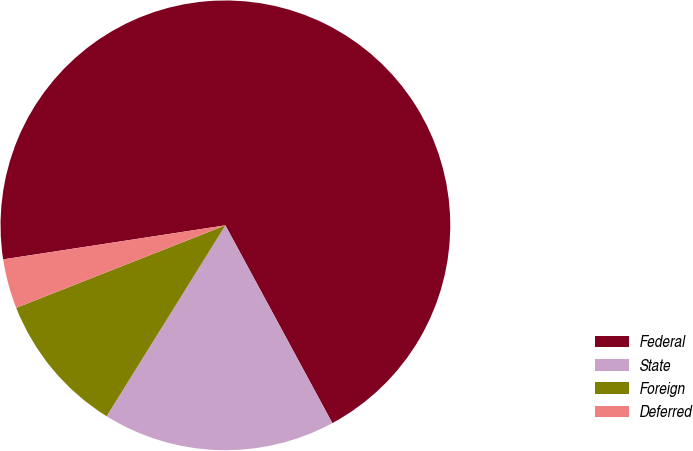Convert chart. <chart><loc_0><loc_0><loc_500><loc_500><pie_chart><fcel>Federal<fcel>State<fcel>Foreign<fcel>Deferred<nl><fcel>69.53%<fcel>16.75%<fcel>10.16%<fcel>3.56%<nl></chart> 